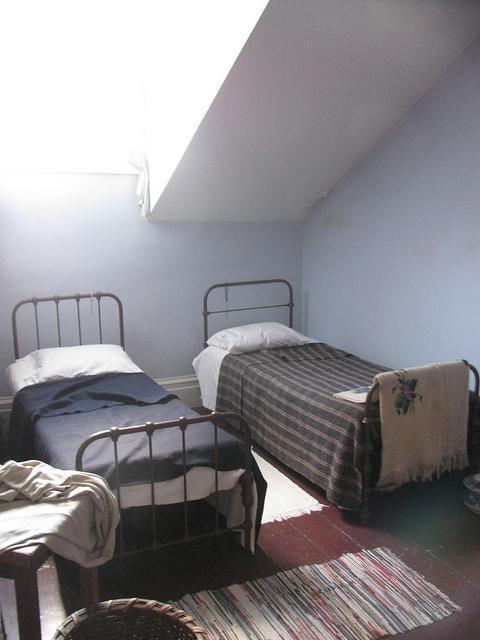How many beds are in the photo?
Give a very brief answer. 2. How many beds are there?
Give a very brief answer. 2. 